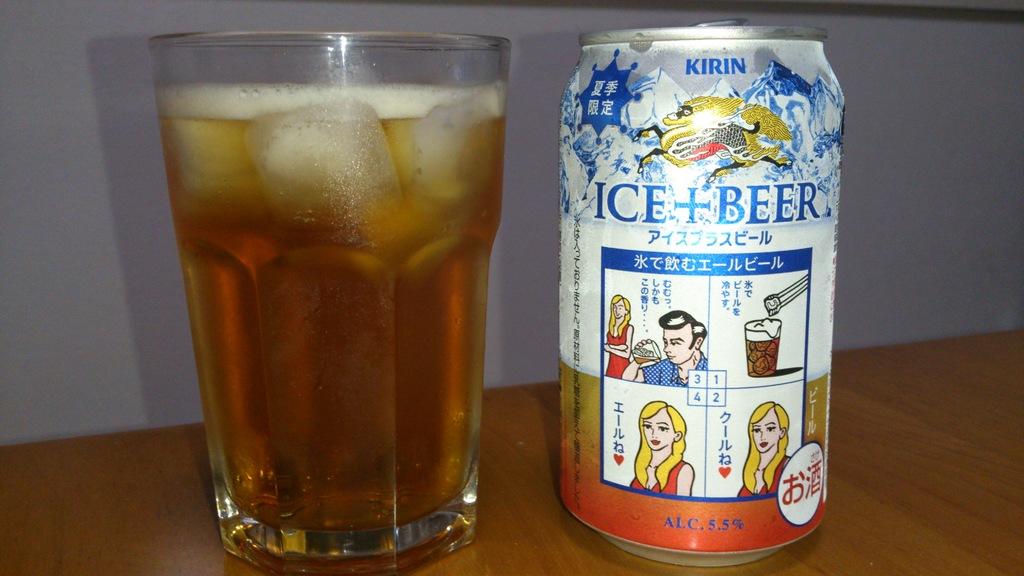What is the alcohol content of the kirin beer?
Make the answer very short. 5.5%. What does the beer can say to add?
Provide a succinct answer. Ice. 